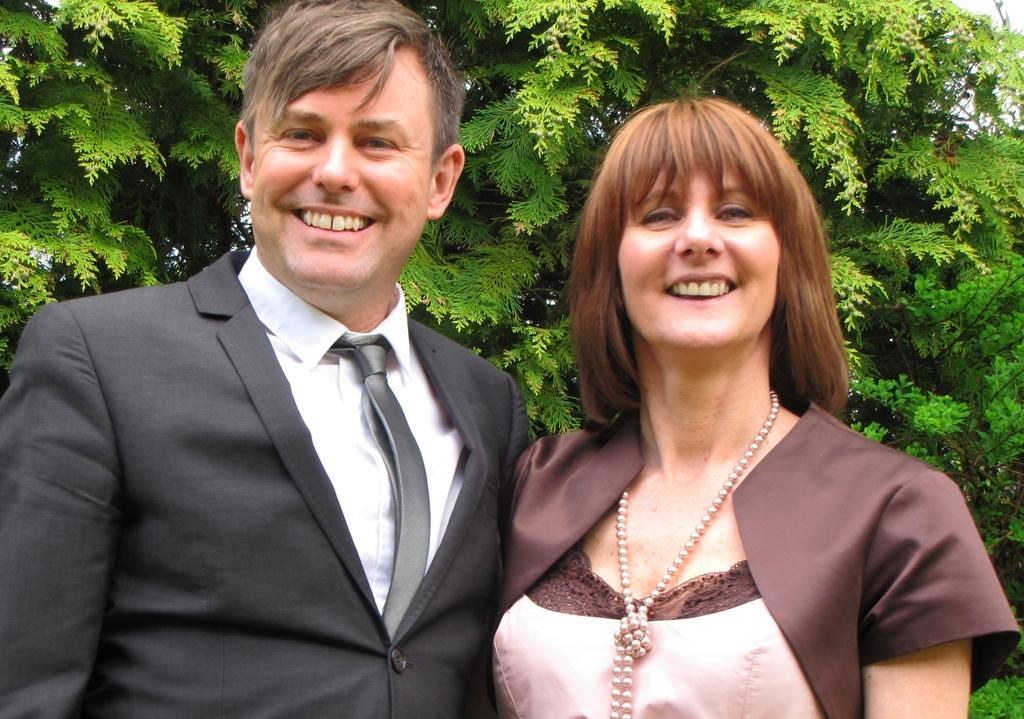Who is present in the image? There is a man and a woman in the image. What are the man and woman doing in the image? The man and woman are standing and laughing. What can be seen in the background of the image? There are trees in the background of the image. How is the sky depicted in the image? The sky is clear in the image. What type of soup is being served in the image? There is no soup present in the image. What class are the man and woman attending in the image? There is no indication of a class or educational setting in the image. 